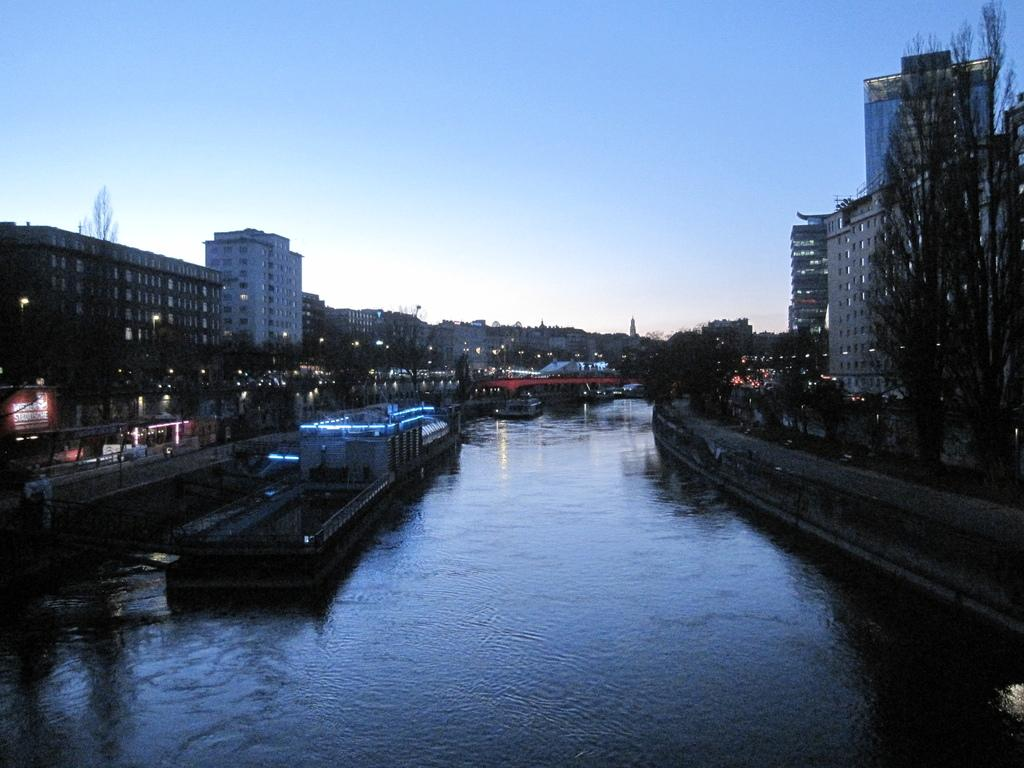What type of vehicles can be seen in the water in the image? There are boats with lights in the water in the image. What structures are visible in the image? There are buildings with windows in the image. What type of vegetation is present in the image? There is a group of trees in the image. What can be seen illuminated in the image? There are lights visible in the image. What is the condition of the sky in the image? The sky is cloudy in the image. Can you tell me how many lizards are climbing on the trees in the image? There are no lizards present in the image; it features boats, buildings, trees, and lights. What type of pickle is being used as a decoration on the boats in the image? There is no pickle present in the image; it features boats with lights in the water. 